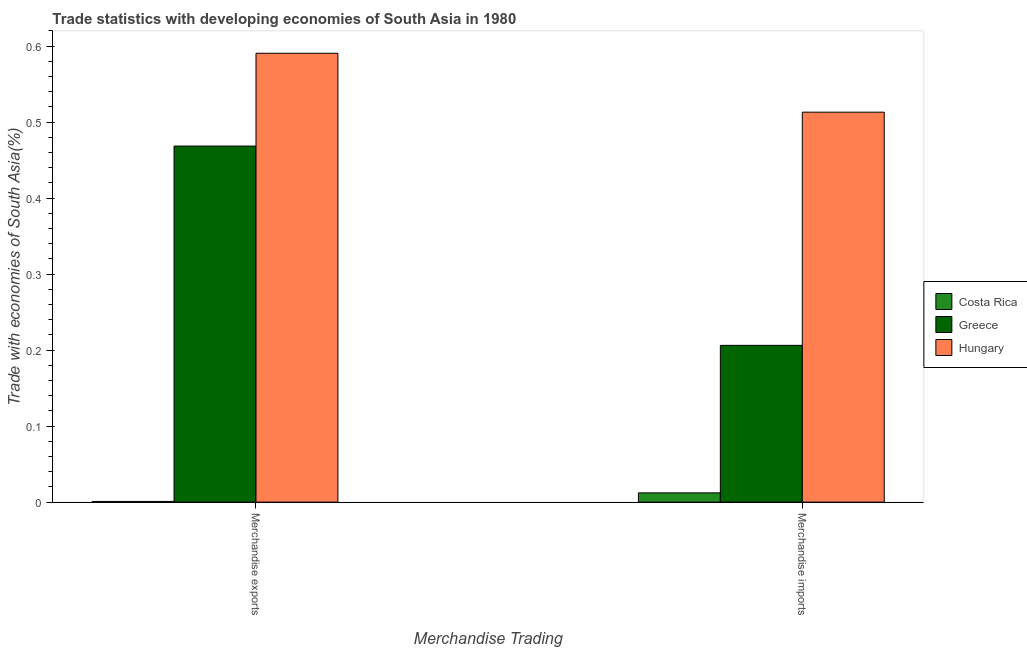What is the label of the 1st group of bars from the left?
Provide a succinct answer. Merchandise exports. What is the merchandise exports in Greece?
Provide a short and direct response. 0.47. Across all countries, what is the maximum merchandise exports?
Provide a succinct answer. 0.59. Across all countries, what is the minimum merchandise exports?
Ensure brevity in your answer.  0. In which country was the merchandise imports maximum?
Offer a very short reply. Hungary. What is the total merchandise exports in the graph?
Give a very brief answer. 1.06. What is the difference between the merchandise exports in Costa Rica and that in Hungary?
Provide a succinct answer. -0.59. What is the difference between the merchandise imports in Hungary and the merchandise exports in Costa Rica?
Your answer should be compact. 0.51. What is the average merchandise imports per country?
Your answer should be very brief. 0.24. What is the difference between the merchandise exports and merchandise imports in Costa Rica?
Your answer should be compact. -0.01. What is the ratio of the merchandise imports in Hungary to that in Costa Rica?
Keep it short and to the point. 42.16. What does the 3rd bar from the left in Merchandise exports represents?
Your answer should be very brief. Hungary. What does the 2nd bar from the right in Merchandise exports represents?
Offer a very short reply. Greece. Does the graph contain any zero values?
Provide a succinct answer. No. Does the graph contain grids?
Ensure brevity in your answer.  No. How many legend labels are there?
Offer a very short reply. 3. What is the title of the graph?
Your answer should be compact. Trade statistics with developing economies of South Asia in 1980. Does "Canada" appear as one of the legend labels in the graph?
Your response must be concise. No. What is the label or title of the X-axis?
Offer a terse response. Merchandise Trading. What is the label or title of the Y-axis?
Make the answer very short. Trade with economies of South Asia(%). What is the Trade with economies of South Asia(%) of Costa Rica in Merchandise exports?
Ensure brevity in your answer.  0. What is the Trade with economies of South Asia(%) of Greece in Merchandise exports?
Offer a very short reply. 0.47. What is the Trade with economies of South Asia(%) in Hungary in Merchandise exports?
Your answer should be very brief. 0.59. What is the Trade with economies of South Asia(%) in Costa Rica in Merchandise imports?
Your answer should be compact. 0.01. What is the Trade with economies of South Asia(%) of Greece in Merchandise imports?
Your response must be concise. 0.21. What is the Trade with economies of South Asia(%) in Hungary in Merchandise imports?
Your answer should be very brief. 0.51. Across all Merchandise Trading, what is the maximum Trade with economies of South Asia(%) in Costa Rica?
Your answer should be compact. 0.01. Across all Merchandise Trading, what is the maximum Trade with economies of South Asia(%) in Greece?
Keep it short and to the point. 0.47. Across all Merchandise Trading, what is the maximum Trade with economies of South Asia(%) of Hungary?
Your response must be concise. 0.59. Across all Merchandise Trading, what is the minimum Trade with economies of South Asia(%) of Costa Rica?
Keep it short and to the point. 0. Across all Merchandise Trading, what is the minimum Trade with economies of South Asia(%) in Greece?
Keep it short and to the point. 0.21. Across all Merchandise Trading, what is the minimum Trade with economies of South Asia(%) in Hungary?
Your response must be concise. 0.51. What is the total Trade with economies of South Asia(%) of Costa Rica in the graph?
Your answer should be very brief. 0.01. What is the total Trade with economies of South Asia(%) in Greece in the graph?
Offer a terse response. 0.67. What is the total Trade with economies of South Asia(%) in Hungary in the graph?
Provide a succinct answer. 1.1. What is the difference between the Trade with economies of South Asia(%) in Costa Rica in Merchandise exports and that in Merchandise imports?
Your answer should be very brief. -0.01. What is the difference between the Trade with economies of South Asia(%) of Greece in Merchandise exports and that in Merchandise imports?
Your response must be concise. 0.26. What is the difference between the Trade with economies of South Asia(%) in Hungary in Merchandise exports and that in Merchandise imports?
Ensure brevity in your answer.  0.08. What is the difference between the Trade with economies of South Asia(%) of Costa Rica in Merchandise exports and the Trade with economies of South Asia(%) of Greece in Merchandise imports?
Offer a very short reply. -0.21. What is the difference between the Trade with economies of South Asia(%) of Costa Rica in Merchandise exports and the Trade with economies of South Asia(%) of Hungary in Merchandise imports?
Make the answer very short. -0.51. What is the difference between the Trade with economies of South Asia(%) in Greece in Merchandise exports and the Trade with economies of South Asia(%) in Hungary in Merchandise imports?
Offer a very short reply. -0.04. What is the average Trade with economies of South Asia(%) in Costa Rica per Merchandise Trading?
Your answer should be very brief. 0.01. What is the average Trade with economies of South Asia(%) in Greece per Merchandise Trading?
Provide a short and direct response. 0.34. What is the average Trade with economies of South Asia(%) in Hungary per Merchandise Trading?
Provide a short and direct response. 0.55. What is the difference between the Trade with economies of South Asia(%) of Costa Rica and Trade with economies of South Asia(%) of Greece in Merchandise exports?
Make the answer very short. -0.47. What is the difference between the Trade with economies of South Asia(%) of Costa Rica and Trade with economies of South Asia(%) of Hungary in Merchandise exports?
Keep it short and to the point. -0.59. What is the difference between the Trade with economies of South Asia(%) of Greece and Trade with economies of South Asia(%) of Hungary in Merchandise exports?
Your answer should be compact. -0.12. What is the difference between the Trade with economies of South Asia(%) of Costa Rica and Trade with economies of South Asia(%) of Greece in Merchandise imports?
Ensure brevity in your answer.  -0.19. What is the difference between the Trade with economies of South Asia(%) of Costa Rica and Trade with economies of South Asia(%) of Hungary in Merchandise imports?
Make the answer very short. -0.5. What is the difference between the Trade with economies of South Asia(%) of Greece and Trade with economies of South Asia(%) of Hungary in Merchandise imports?
Provide a succinct answer. -0.31. What is the ratio of the Trade with economies of South Asia(%) in Costa Rica in Merchandise exports to that in Merchandise imports?
Keep it short and to the point. 0.08. What is the ratio of the Trade with economies of South Asia(%) in Greece in Merchandise exports to that in Merchandise imports?
Keep it short and to the point. 2.27. What is the ratio of the Trade with economies of South Asia(%) of Hungary in Merchandise exports to that in Merchandise imports?
Provide a succinct answer. 1.15. What is the difference between the highest and the second highest Trade with economies of South Asia(%) of Costa Rica?
Offer a terse response. 0.01. What is the difference between the highest and the second highest Trade with economies of South Asia(%) in Greece?
Give a very brief answer. 0.26. What is the difference between the highest and the second highest Trade with economies of South Asia(%) in Hungary?
Provide a short and direct response. 0.08. What is the difference between the highest and the lowest Trade with economies of South Asia(%) of Costa Rica?
Ensure brevity in your answer.  0.01. What is the difference between the highest and the lowest Trade with economies of South Asia(%) of Greece?
Make the answer very short. 0.26. What is the difference between the highest and the lowest Trade with economies of South Asia(%) of Hungary?
Keep it short and to the point. 0.08. 